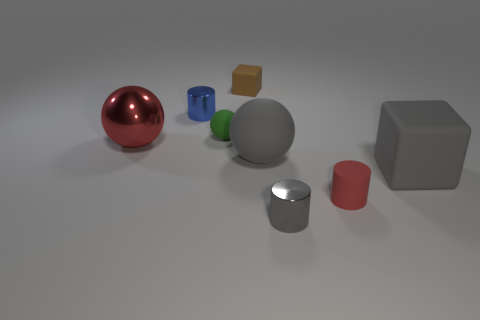Add 1 tiny brown matte things. How many objects exist? 9 Subtract all blocks. How many objects are left? 6 Subtract all small gray cylinders. Subtract all green balls. How many objects are left? 6 Add 8 tiny gray objects. How many tiny gray objects are left? 9 Add 8 large yellow metallic spheres. How many large yellow metallic spheres exist? 8 Subtract 1 red cylinders. How many objects are left? 7 